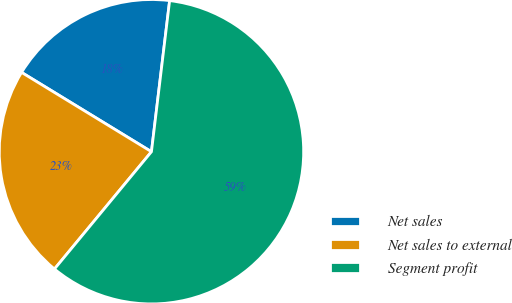<chart> <loc_0><loc_0><loc_500><loc_500><pie_chart><fcel>Net sales<fcel>Net sales to external<fcel>Segment profit<nl><fcel>18.18%<fcel>22.73%<fcel>59.09%<nl></chart> 